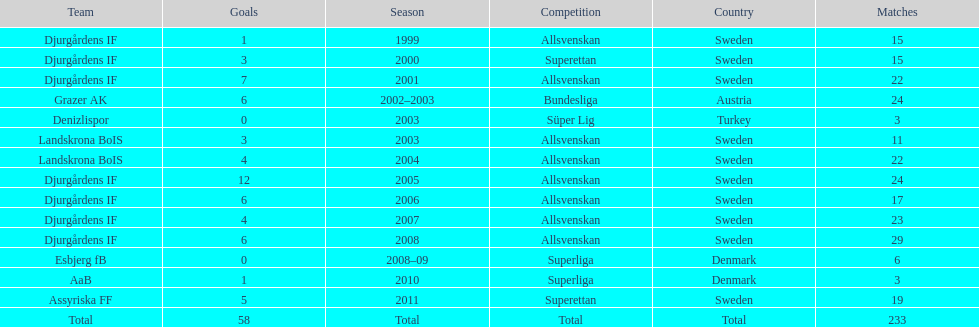How many matches overall were there? 233. 